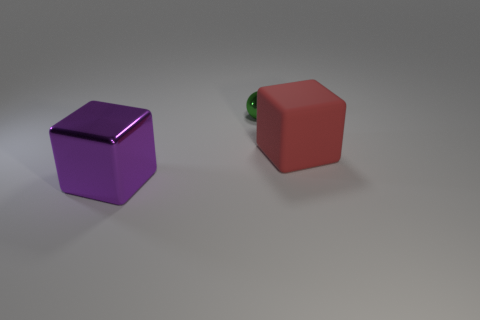Is there any other thing that has the same size as the green metallic object?
Ensure brevity in your answer.  No. Is the number of big red objects right of the red rubber cube less than the number of big blocks to the right of the big purple thing?
Give a very brief answer. Yes. There is a block left of the large block behind the shiny cube; is there a large thing right of it?
Provide a succinct answer. Yes. Does the large object in front of the red block have the same shape as the large object right of the large purple shiny cube?
Provide a short and direct response. Yes. There is a thing that is the same size as the matte block; what is it made of?
Provide a short and direct response. Metal. Is the thing that is left of the small green ball made of the same material as the small ball that is to the right of the purple thing?
Offer a terse response. Yes. The purple thing that is the same size as the red matte object is what shape?
Ensure brevity in your answer.  Cube. How many other objects are there of the same color as the large matte block?
Provide a succinct answer. 0. What is the color of the cube on the right side of the purple block?
Keep it short and to the point. Red. What number of other objects are there of the same material as the big purple thing?
Provide a short and direct response. 1. 